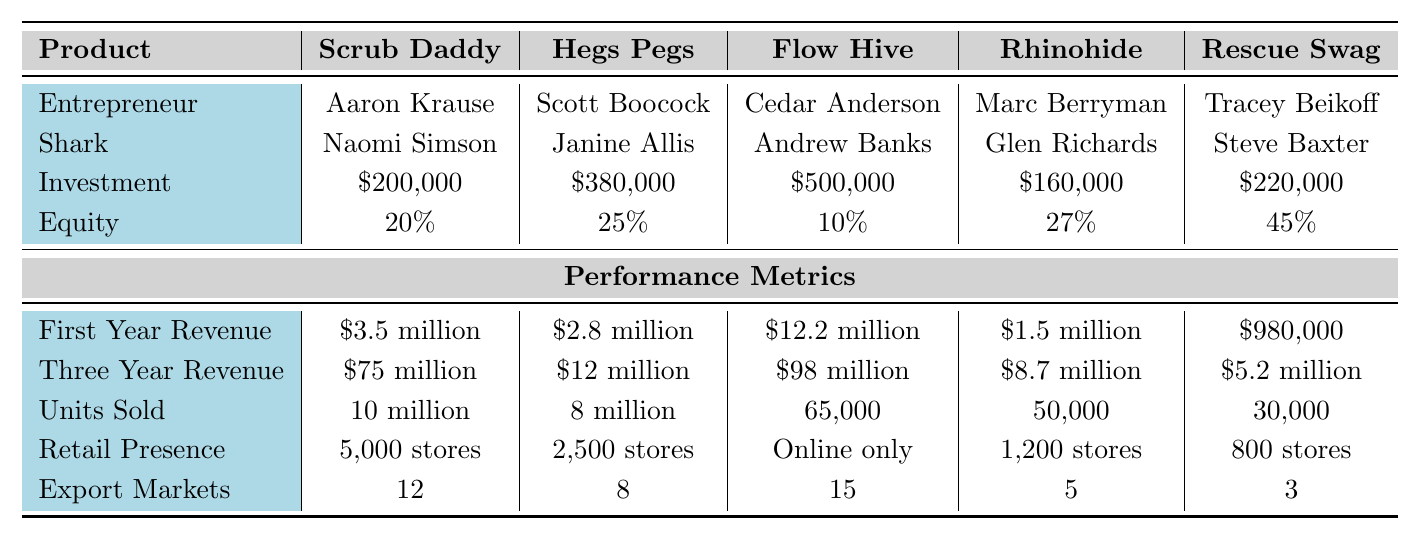What is the total investment from the Sharks for the top 5 products? To find the total investment, sum the investments of all five products: $200,000 + $380,000 + $500,000 + $160,000 + $220,000 = $1,460,000.
Answer: $1,460,000 Which product has the highest three-year revenue? Looking at the "Three Year Revenue" row, the highest value is $98 million corresponding to the product "Flow Hive."
Answer: Flow Hive How many units were sold in total across all products? To find the total units sold, sum the units sold: 10 million + 8 million + 65,000 + 50,000 + 30,000. First convert everything to the same unit: 10 million = 10,000,000 and 8 million = 8,000,000. So, 10,000,000 + 8,000,000 + 65,000 + 50,000 + 30,000 = 18,115,000 units.
Answer: 18,115,000 units Did any product have an equity share greater than 30%? Comparing the equity percentages, "Hegs Pegs" has 25%, "Rhinohide" has 27%, and "Rescue Swag" has 45%, which is greater than 30%. Therefore, the answer is yes.
Answer: Yes What percentage of total investments does "Scrub Daddy" represent? First, find the investment of "Scrub Daddy" which is $200,000, and then use the total investment of $1,460,000 calculated earlier. Now, divide $200,000 by $1,460,000, and multiply by 100 to convert it to a percentage: ($200,000 / $1,460,000) * 100 = 13.70%.
Answer: 13.70% Which Shark invested the least amount, and in which product? The investments are $200,000 for "Scrub Daddy," $380,000 for "Hegs Pegs," $500,000 for "Flow Hive," $160,000 for "Rhinohide," and $220,000 for "Rescue Swag." The least amount is $160,000. The corresponding product is "Rhinohide."
Answer: Rhinohide What is the average first-year revenue of the top 5 products? To find the average, sum the first-year revenues: $3.5 million + $2.8 million + $12.2 million + $1.5 million + $980,000. Convert each to millions for easier calculation: $3.5 + $2.8 + $12.2 + $1.5 + $0.98 = $21.02 million. Then divide by 5 (the number of products): $21.02 million / 5 = $4.204 million.
Answer: $4.204 million How many retail stores does "Flow Hive" have a presence in? The retail presence for "Flow Hive" is listed as "Online only," which means it doesn't have a presence in physical retail stores.
Answer: Online only Is "Rescue Swag" the product with the lowest first-year revenue? Comparing the first-year revenues, "Rescue Swag" has $980,000, while "Rhinohide" has $1.5 million, "$2.8 million" for "Hegs Pegs," "$3.5 million" for "Scrub Daddy," and "$12.2 million" for "Flow Hive." Therefore, yes, it is the lowest.
Answer: Yes What is the difference in two-year revenue between "Flow Hive" and "Hegs Pegs"? The three-year revenue for "Flow Hive" is $98 million, and for "Hegs Pegs," it is $12 million. Find the difference: $98 million - $12 million = $86 million.
Answer: $86 million 